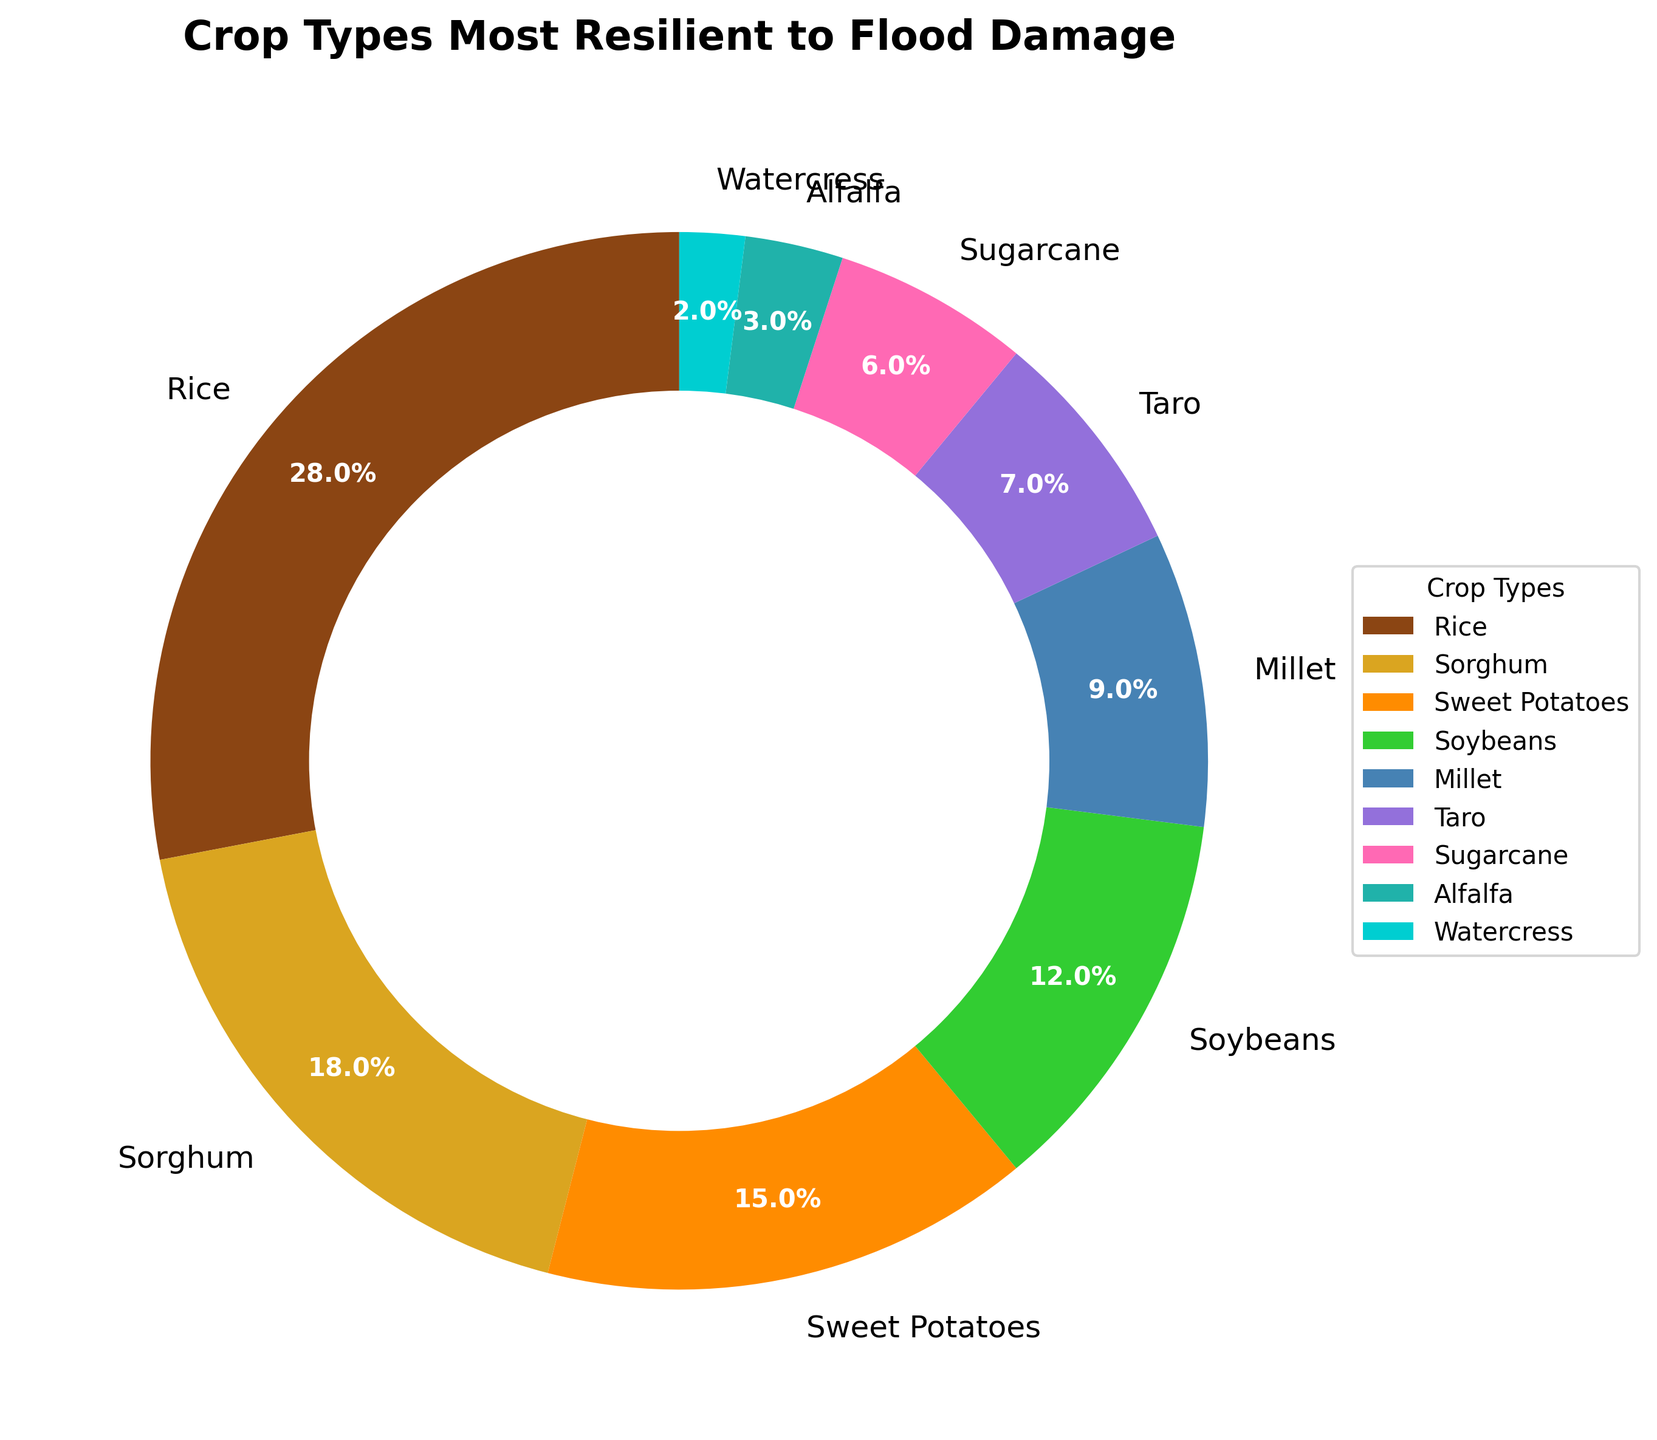What's the most resilient crop type to flood damage according to the pie chart? The largest segment in the pie chart represents the crop type most resilient to flood damage. In this case, it is "Rice" with 28% of the total.
Answer: Rice Which crop type is the least resilient to flood damage? The smallest segment in the pie chart represents the crop type least resilient to flood damage. This is "Watercress" with 2% of the total.
Answer: Watercress How much more resilient is Sorghum compared to Sugarcane? According to the pie chart, Sorghum contributes 18%, and Sugarcane contributes 6%. The difference in resilience percentage is 18% - 6% = 12%.
Answer: 12% What is the combined percentage of Sweet Potatoes and Alfalfa? From the pie chart, Sweet Potatoes have 15% and Alfalfa has 3%. Adding these together gives 15% + 3% = 18%.
Answer: 18% Are Soybeans more resilient than Millet according to the pie chart? From the pie chart, Soybeans have 12%, and Millet has 9%. Therefore, Soybeans are more resilient than Millet.
Answer: Yes Which crop type is represented by the dark orange segment in the pie chart? The dark orange segment in the pie chart represents "Sweet Potatoes," as Sweet Potatoes are associated with approximately 15% of the chart, and their color matches dark orange.
Answer: Sweet Potatoes By how much does Taro's resilience percentage differ from Alfalfa's? According to the chart, Taro has 7% resilience, and Alfalfa has 3%. The difference is calculated as 7% - 3% = 4%.
Answer: 4% What is the total percentage of crops that are less resilient than Soybeans? Crops less resilient than Soybeans have percentages as follows: Millet 9%, Taro 7%, Sugarcane 6%, Alfalfa 3%, and Watercress 2%. Adding these together: 9% + 7% + 6% + 3% + 2% = 27%.
Answer: 27% Which crop types are in the top three most resilient to flood damage? The top three segments in the pie chart (in terms of their percentages) are: Rice (28%), Sorghum (18%), and Sweet Potatoes (15%).
Answer: Rice, Sorghum, Sweet Potatoes 